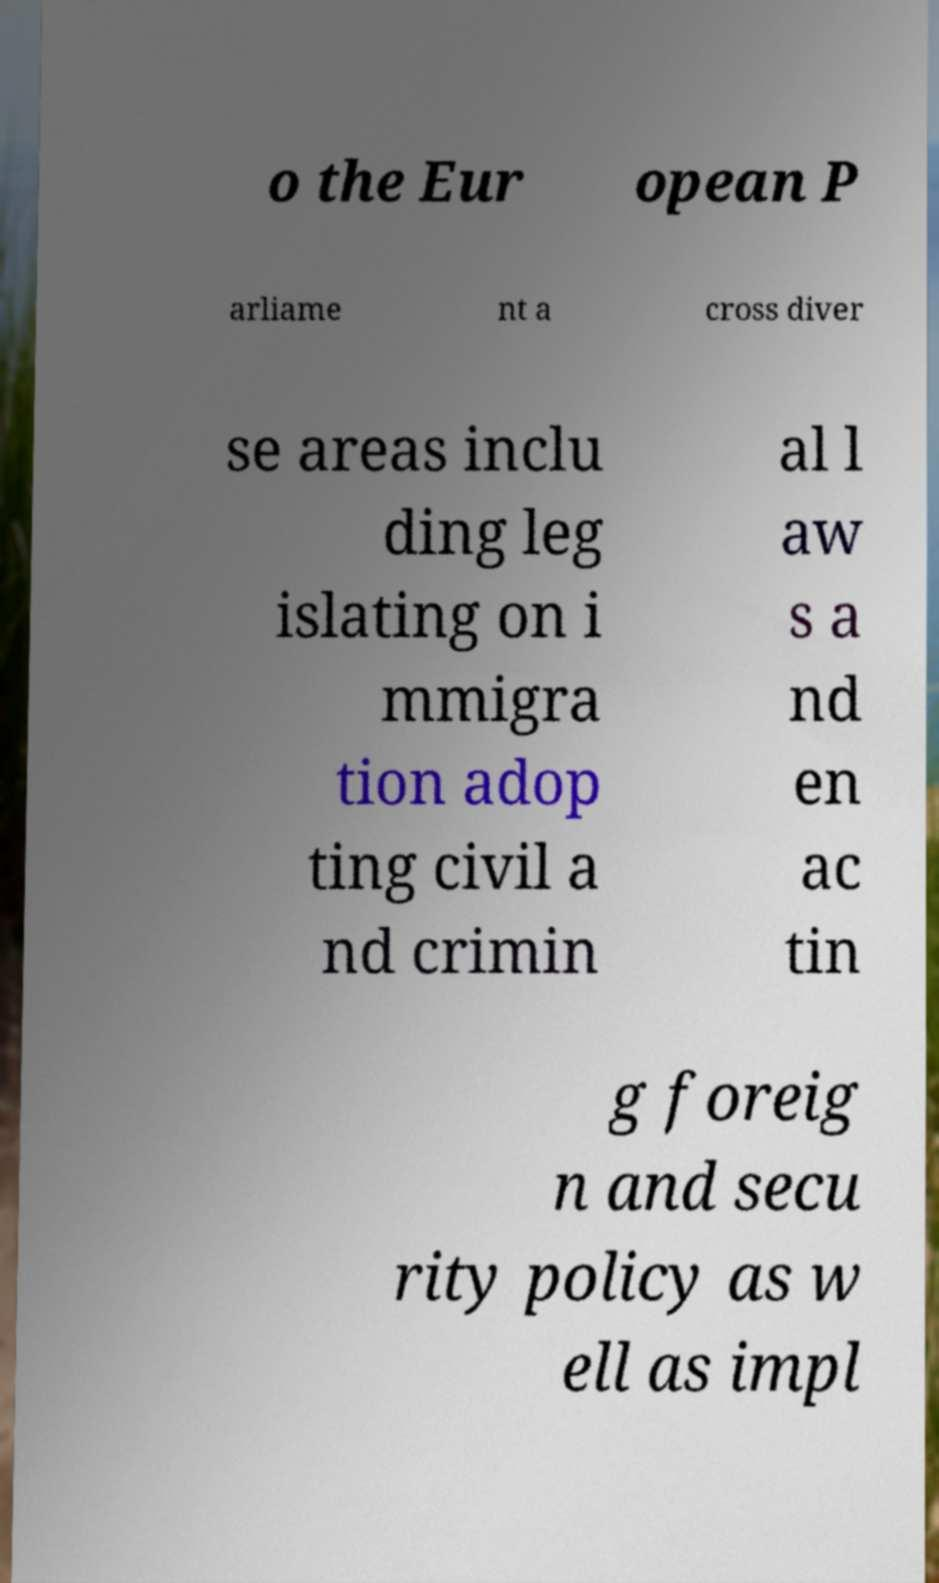I need the written content from this picture converted into text. Can you do that? o the Eur opean P arliame nt a cross diver se areas inclu ding leg islating on i mmigra tion adop ting civil a nd crimin al l aw s a nd en ac tin g foreig n and secu rity policy as w ell as impl 